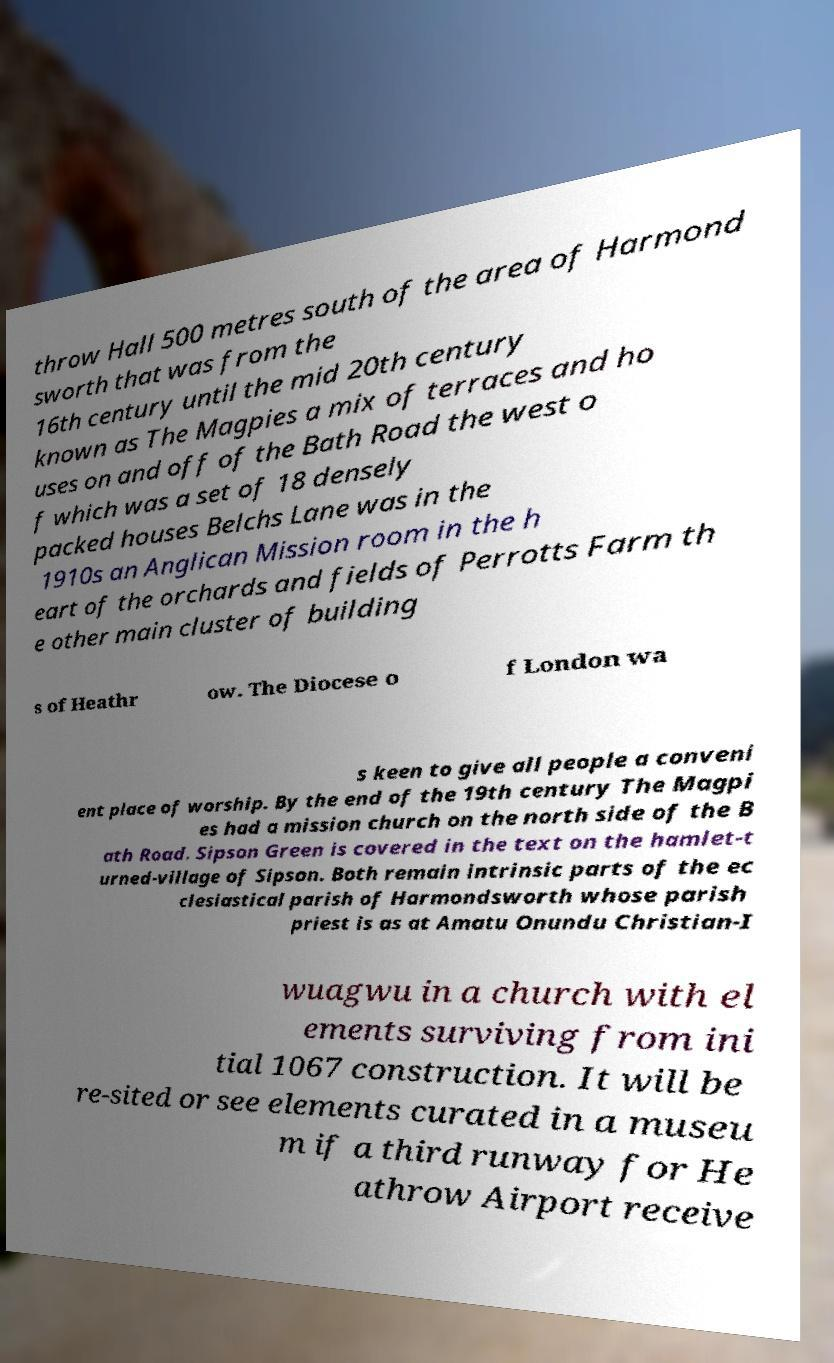Please identify and transcribe the text found in this image. throw Hall 500 metres south of the area of Harmond sworth that was from the 16th century until the mid 20th century known as The Magpies a mix of terraces and ho uses on and off of the Bath Road the west o f which was a set of 18 densely packed houses Belchs Lane was in the 1910s an Anglican Mission room in the h eart of the orchards and fields of Perrotts Farm th e other main cluster of building s of Heathr ow. The Diocese o f London wa s keen to give all people a conveni ent place of worship. By the end of the 19th century The Magpi es had a mission church on the north side of the B ath Road. Sipson Green is covered in the text on the hamlet-t urned-village of Sipson. Both remain intrinsic parts of the ec clesiastical parish of Harmondsworth whose parish priest is as at Amatu Onundu Christian-I wuagwu in a church with el ements surviving from ini tial 1067 construction. It will be re-sited or see elements curated in a museu m if a third runway for He athrow Airport receive 